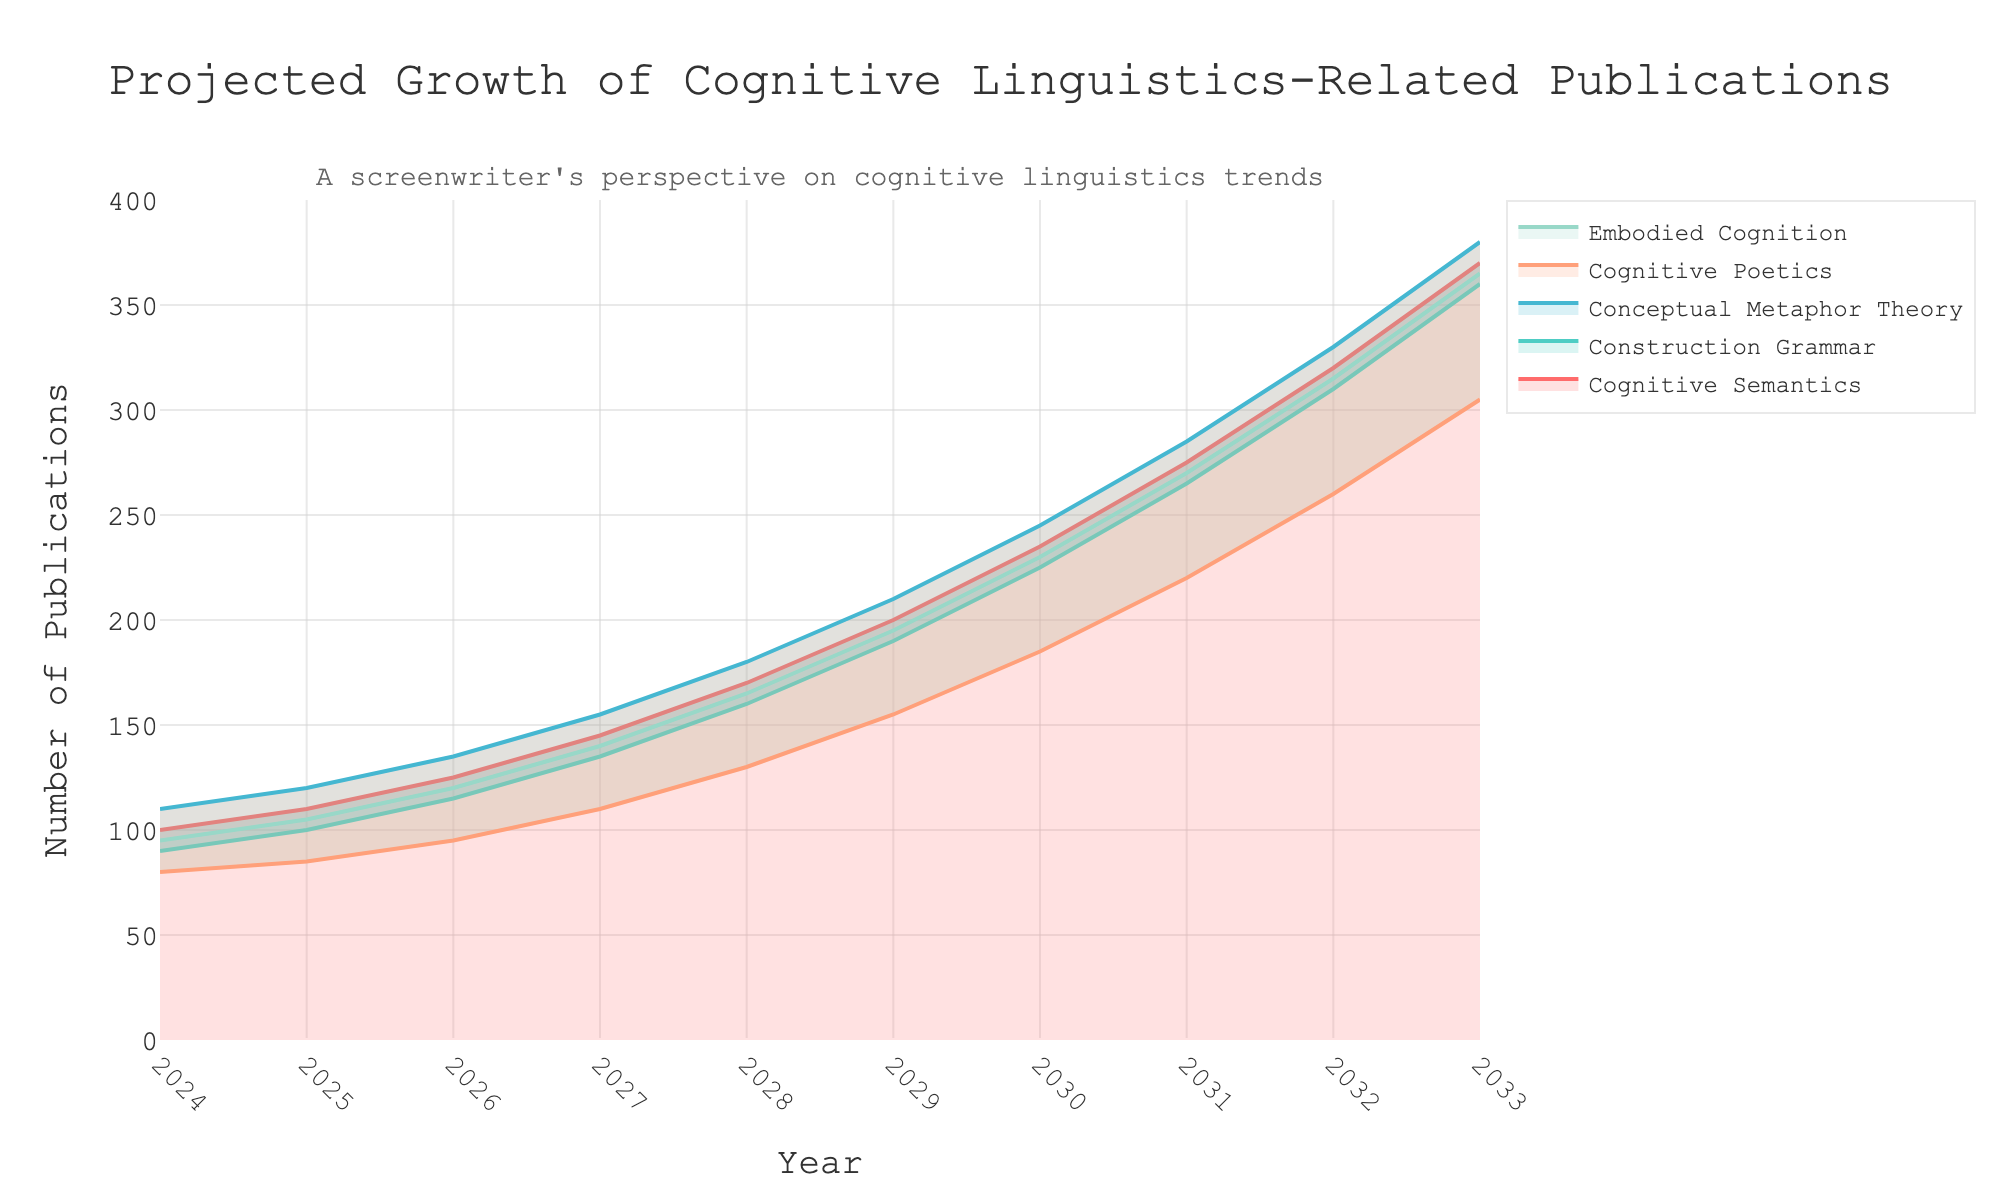Which subfield has the highest number of projected publications in 2033? Look at the values on the y-axis for the year 2033 for each subfield. The highest value is 380 for "Conceptual Metaphor Theory".
Answer: Conceptual Metaphor Theory What is the projected number of publications for "Cognitive Poetics" in 2028? Locate the point for "Cognitive Poetics" on the x-axis at the year 2028, then check its corresponding y-value, which is 130.
Answer: 130 Which subfield sees the steepest growth between 2024 and 2033? Observe the lines representing each subfield and calculate the difference in values between 2024 and 2033. "Conceptual Metaphor Theory" grows from 110 to 380, a change of 270, which is the steepest.
Answer: Conceptual Metaphor Theory How does the growth of "Embodied Cognition" compare to "Construction Grammar" from 2024 to 2029? Calculate the increase in publications for both subfields. "Embodied Cognition" grows from 95 to 195 (an increase of 100), and "Construction Grammar" grows from 90 to 190 (an increase of 100). Both subfields experience the same growth.
Answer: Same growth What is the average projected number of publications for "Cognitive Semantics" from 2024 to 2028? Sum the values of "Cognitive Semantics" from 2024 to 2028 (100 + 110 + 125 + 145 + 170) and divide by the number of years, which is 5. The sum is 650, so the average is 650 / 5 = 130.
Answer: 130 Which year shows the largest increase in projected publications for "Conceptual Metaphor Theory"? To find the largest increase, check the year-to-year differences for "Conceptual Metaphor Theory". The largest difference is between 2032 and 2033, where it increases from 330 to 380, a change of 50.
Answer: 2033 By how much does the projected number of publications in “Cognitive Semantics” increase from 2026 to 2029? Determine the number in 2026 (125) and the number in 2029 (200), then subtract the former from the latter. 200 - 125 = 75.
Answer: 75 If the trend continues, which subfield could potentially reach 400 publications first? Looking at the growth rates of each subfield, "Conceptual Metaphor Theory" is projected to reach 380 by 2033. Assuming a linear trend, it would surpass 400 soon after 2033.
Answer: Conceptual Metaphor Theory How many years will it take “Construction Grammar” to double its projected number of publications from its 2024 value? The 2024 value is 90. To double, it needs to reach 180. According to the chart, “Construction Grammar” reaches 180 in 2028. From 2024 to 2028 is 4 years.
Answer: 4 years 